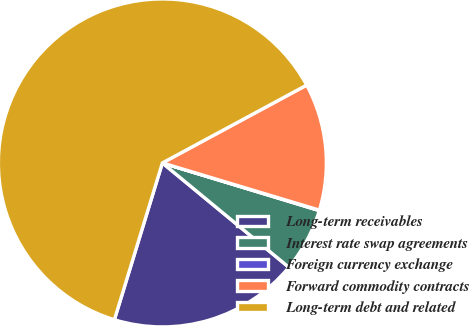<chart> <loc_0><loc_0><loc_500><loc_500><pie_chart><fcel>Long-term receivables<fcel>Interest rate swap agreements<fcel>Foreign currency exchange<fcel>Forward commodity contracts<fcel>Long-term debt and related<nl><fcel>18.75%<fcel>6.28%<fcel>0.05%<fcel>12.52%<fcel>62.4%<nl></chart> 